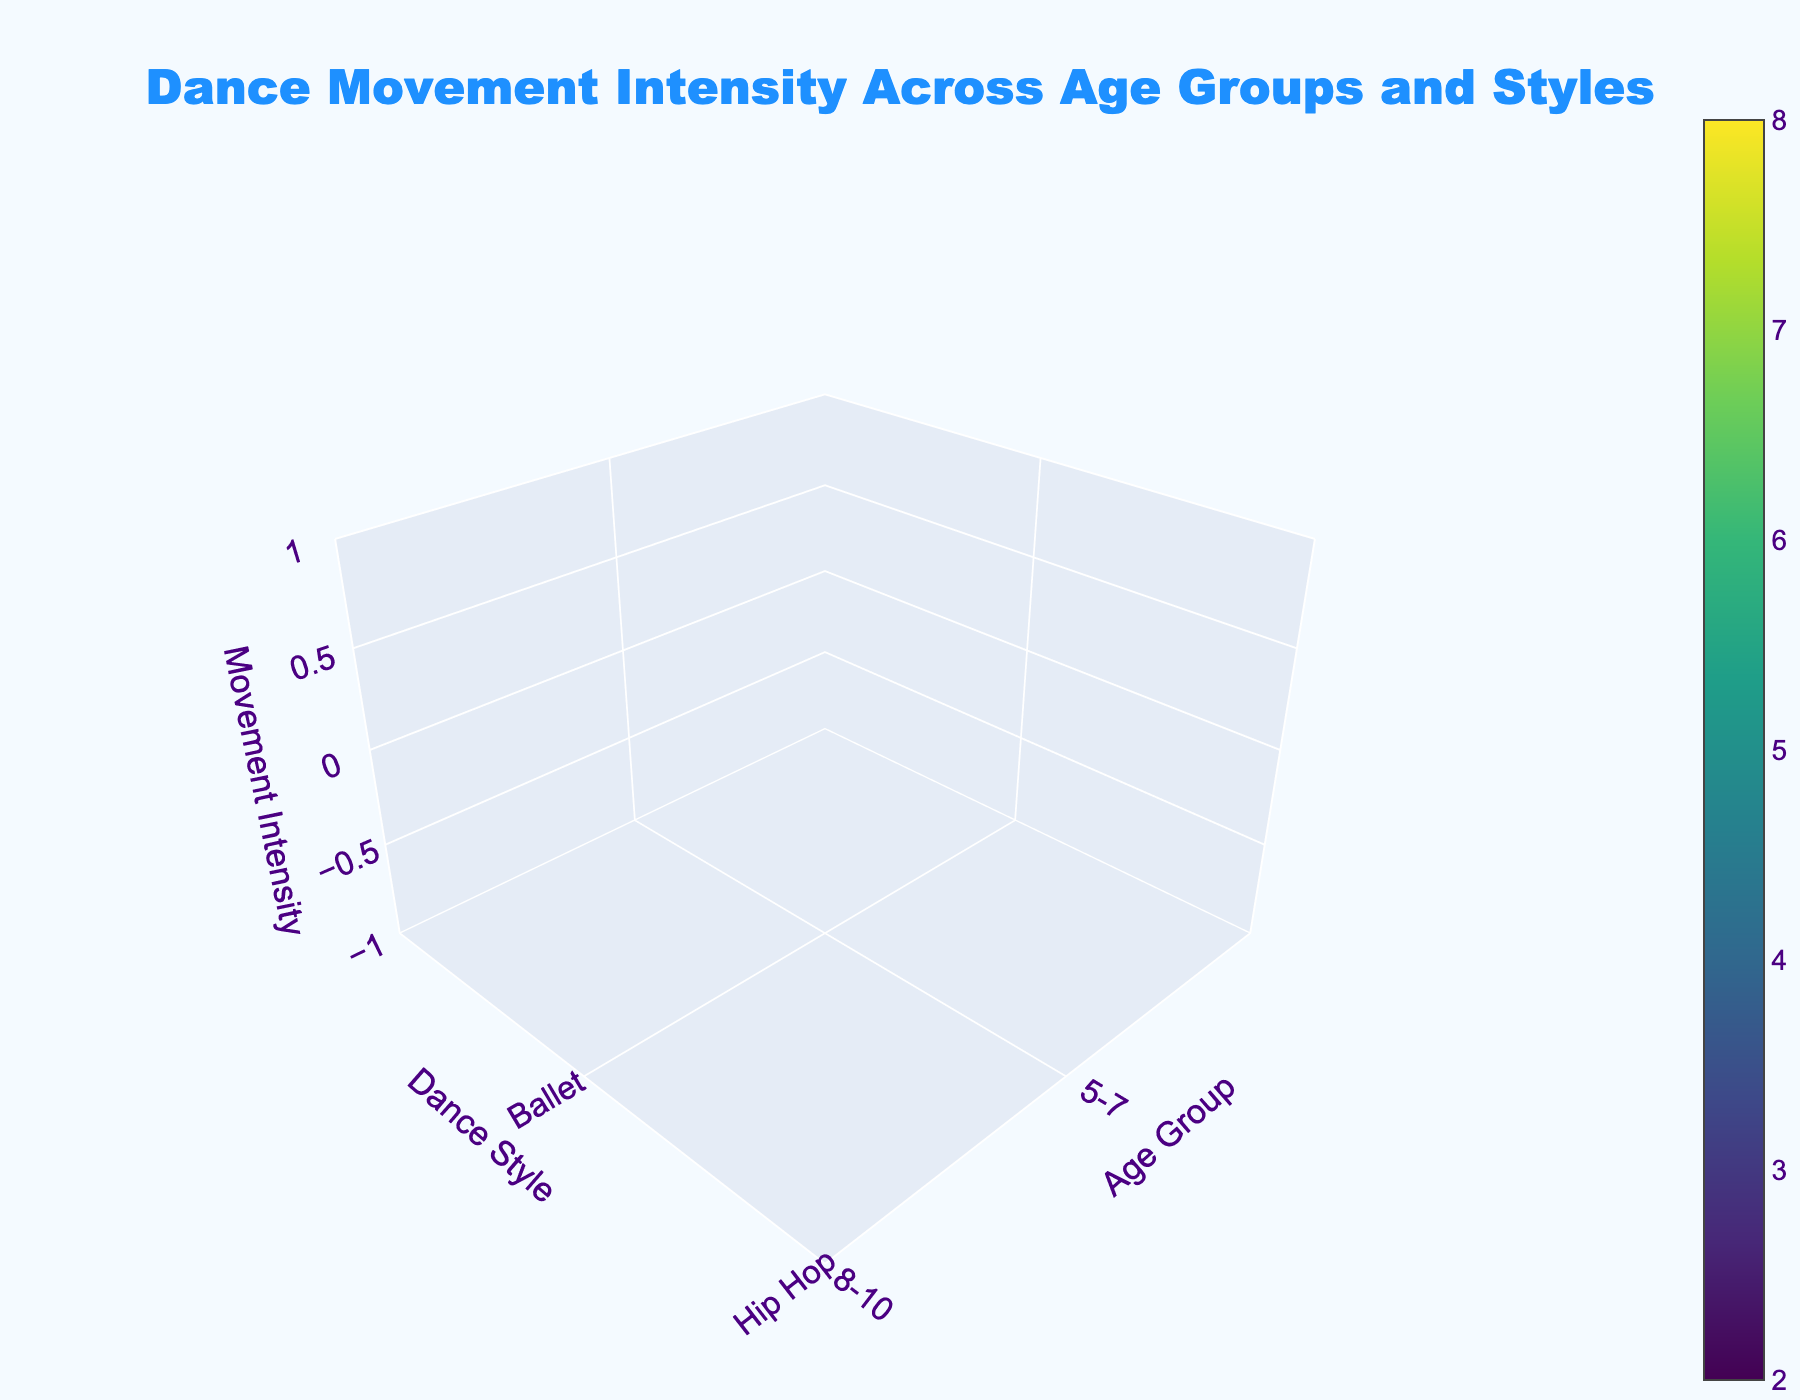What is the title of the plot? Reading the title at the top of the plot, we see "Dance Movement Intensity Across Age Groups and Styles."
Answer: Dance Movement Intensity Across Age Groups and Styles How many age groups are displayed in the plot? By counting the labels on the x-axis, we see there are five distinct age groups.
Answer: 5 Which dance style shows the highest movement intensity for the age group 8-10? By looking at the z-axis values for each dance style in the 8-10 age group, the highest value is 5 for Hip Hop.
Answer: Hip Hop What is the movement intensity for Ballet in the 14-16 age group? Locate the intersection of Ballet and 14-16 on the plot and read the z-axis value, which is 5.
Answer: 5 Which dance style has the lowest movement intensity in the 17-18 age group? Check the z-axis values for the 17-18 age group and identify the smallest value, which is 6 for Ballet.
Answer: Ballet What is the average movement intensity for Jazz across all age groups? Sum the movement intensities for Jazz across all age groups (3 + 4 + 5 + 6 + 7 = 25) and divide by the number of age groups (5). The average is 25/5 = 5.
Answer: 5 Which age group shows the highest movement intensity overall? Compare the movement intensities across all dance styles for each age group. The age group 17-18 has the highest values overall.
Answer: 17-18 How does the movement intensity of Hip Hop change as the age group increases? Observe the z-axis values for Hip Hop across different age groups: 4, 5, 6, 7, and 8. It shows a consistent increase as age increases.
Answer: Increases Is the movement intensity for Ballet ever higher than for Hip Hop in any age group? Compare the z-axis values of Ballet and Hip Hop for each age group: 5-7 (2 vs 4), 8-10 (3 vs 5), 11-13 (4 vs 6), 14-16 (5 vs 7), 17-18 (6 vs 8). Ballet is never higher than Hip Hop in any age group.
Answer: No What is the difference in movement intensity between the youngest and oldest age groups for Jazz? The movement intensity for Jazz in the 5-7 age group is 3, and for the 17-18 age group, it is 7. The difference is 7 - 3 = 4.
Answer: 4 